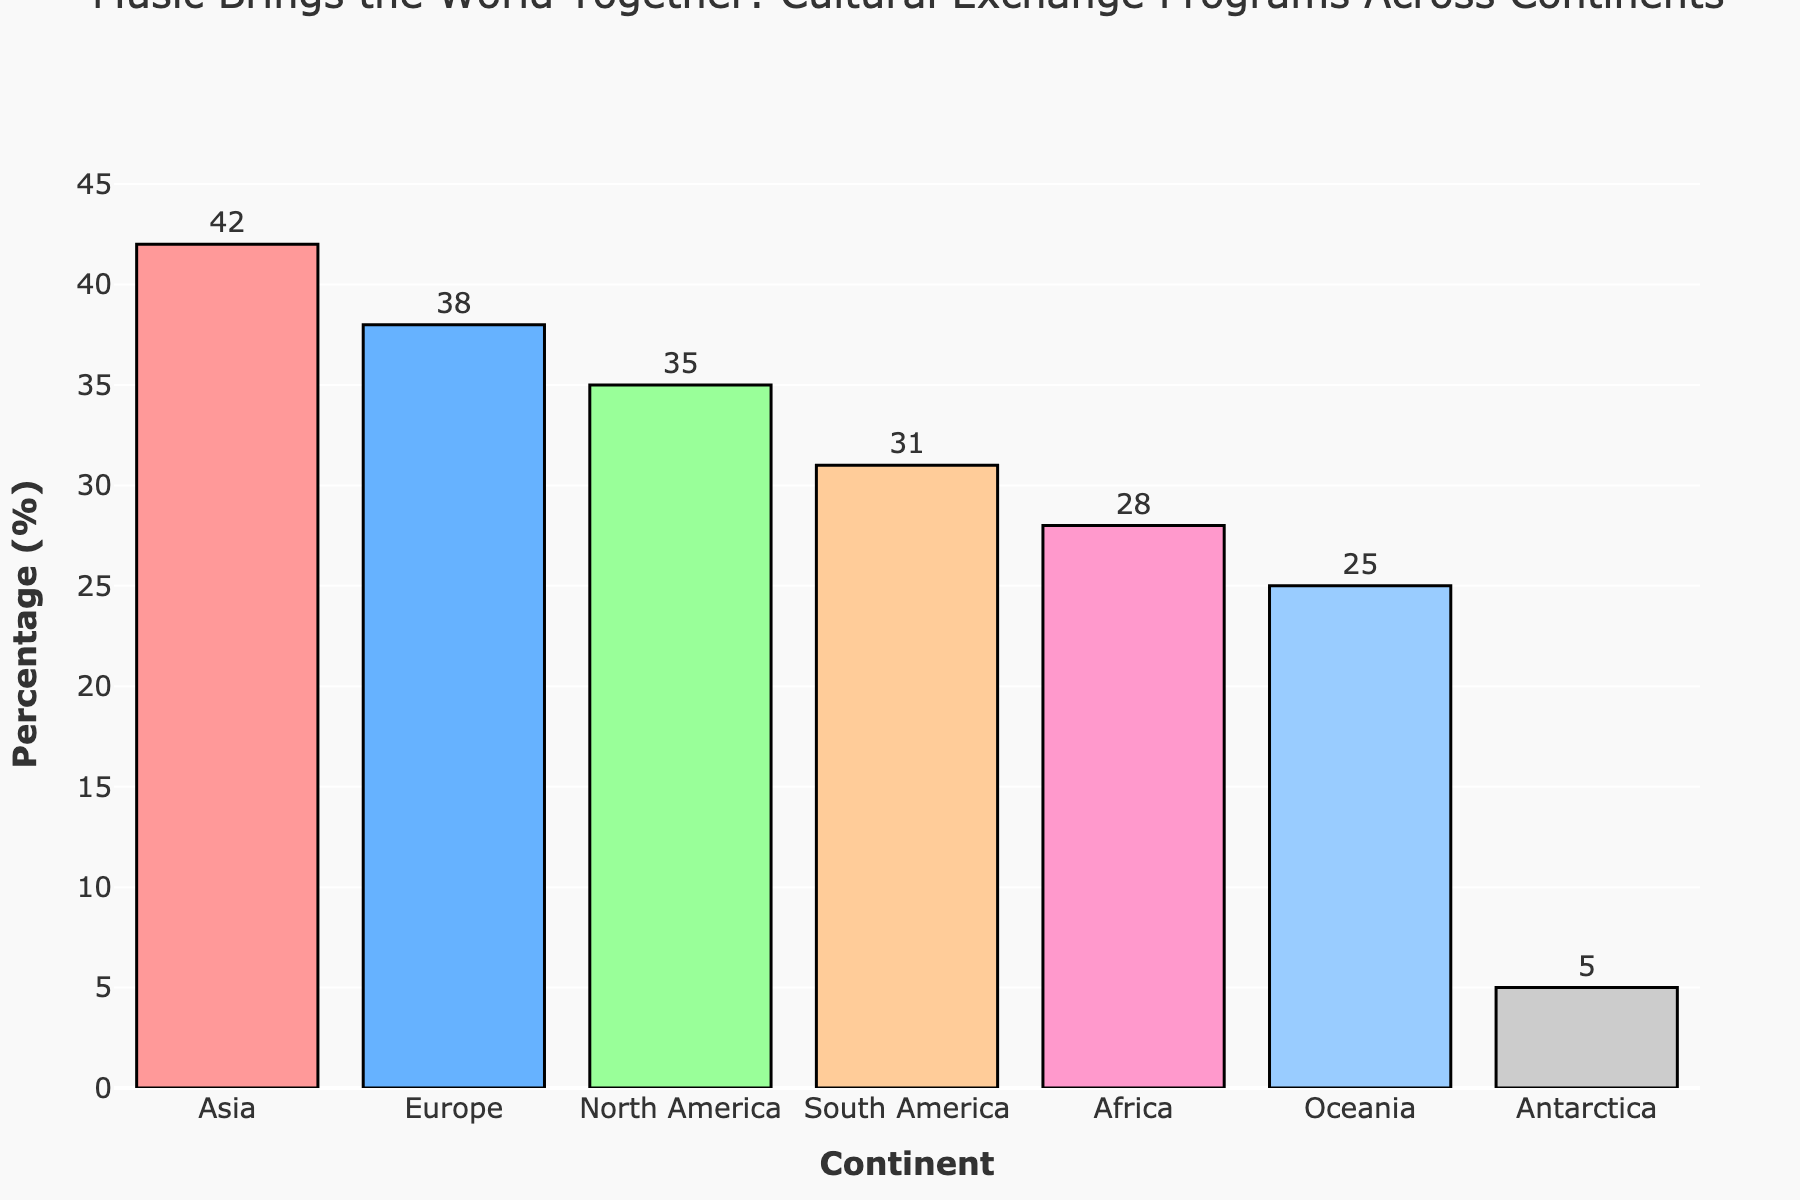Which continent has the highest percentage of music-focused cultural exchange programs? Asia has the highest percentage of music-focused cultural exchange programs, as the tallest bar represents Asia.
Answer: Asia What is the difference in percentage of music-focused cultural exchange programs between Asia and Oceania? The percentage for Asia is 42%, and for Oceania, it's 25%. The difference between them is 42% - 25% = 17%.
Answer: 17% Which continents have a music-focused cultural exchange program percentage greater than 30%? By examining the bars, Asia (42%), Europe (38%), North America (35%), and South America (31%) each have percentages greater than 30%.
Answer: Asia, Europe, North America, South America Is there any continent where the percentage of music-focused cultural exchange programs is below 10%? The bar for Antarctica shows a percentage of 5%, which is below 10%.
Answer: Antarctica What is the total percentage of music-focused cultural exchange programs for North America and South America combined? North America has 35%, and South America has 31%. Adding them together gives 35% + 31% = 66%.
Answer: 66% How does the percentage of music-focused cultural exchange programs in Europe compare to that in Africa? The percentage in Europe is 38%, while in Africa, it is 28%. Europe has a higher percentage than Africa (38% > 28%).
Answer: Europe > Africa What percentage of music-focused cultural exchange programs are in Antarctica, and how does it compare to Oceania? Antarctica has a 5% of music-focused programs, and Oceania has 25%. Oceania has a higher percentage than Antarctica (25% > 5%).
Answer: Antarctica = 5%, Oceania > Antarctica What is the average percentage of music-focused cultural exchange programs in Asia, Europe, and North America? The percentages are 42% for Asia, 38% for Europe, and 35% for North America. The sum is 42% + 38% + 35% = 115%, and the average is 115% / 3 = 38.33%.
Answer: 38.33% Which continent has the least percentage of music-focused cultural exchange programs, and what is its value? The smallest bar represents Antarctica, which has the lowest percentage of music-focused cultural exchange programs at 5%.
Answer: Antarctica, 5% What is the difference between the highest and lowest percentages of music-focused cultural exchange programs? The highest percentage is in Asia (42%) and the lowest in Antarctica (5%). The difference is 42% - 5% = 37%.
Answer: 37% 